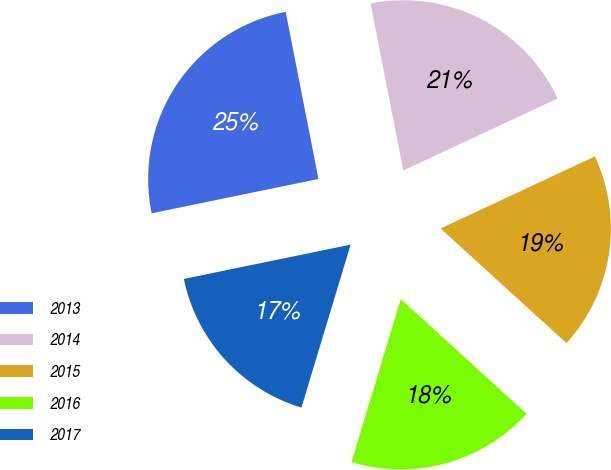<chart> <loc_0><loc_0><loc_500><loc_500><pie_chart><fcel>2013<fcel>2014<fcel>2015<fcel>2016<fcel>2017<nl><fcel>25.15%<fcel>21.13%<fcel>18.71%<fcel>17.91%<fcel>17.1%<nl></chart> 